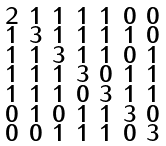Convert formula to latex. <formula><loc_0><loc_0><loc_500><loc_500>\begin{smallmatrix} 2 & 1 & 1 & 1 & 1 & 0 & 0 \\ 1 & 3 & 1 & 1 & 1 & 1 & 0 \\ 1 & 1 & 3 & 1 & 1 & 0 & 1 \\ 1 & 1 & 1 & 3 & 0 & 1 & 1 \\ 1 & 1 & 1 & 0 & 3 & 1 & 1 \\ 0 & 1 & 0 & 1 & 1 & 3 & 0 \\ 0 & 0 & 1 & 1 & 1 & 0 & 3 \end{smallmatrix}</formula> 